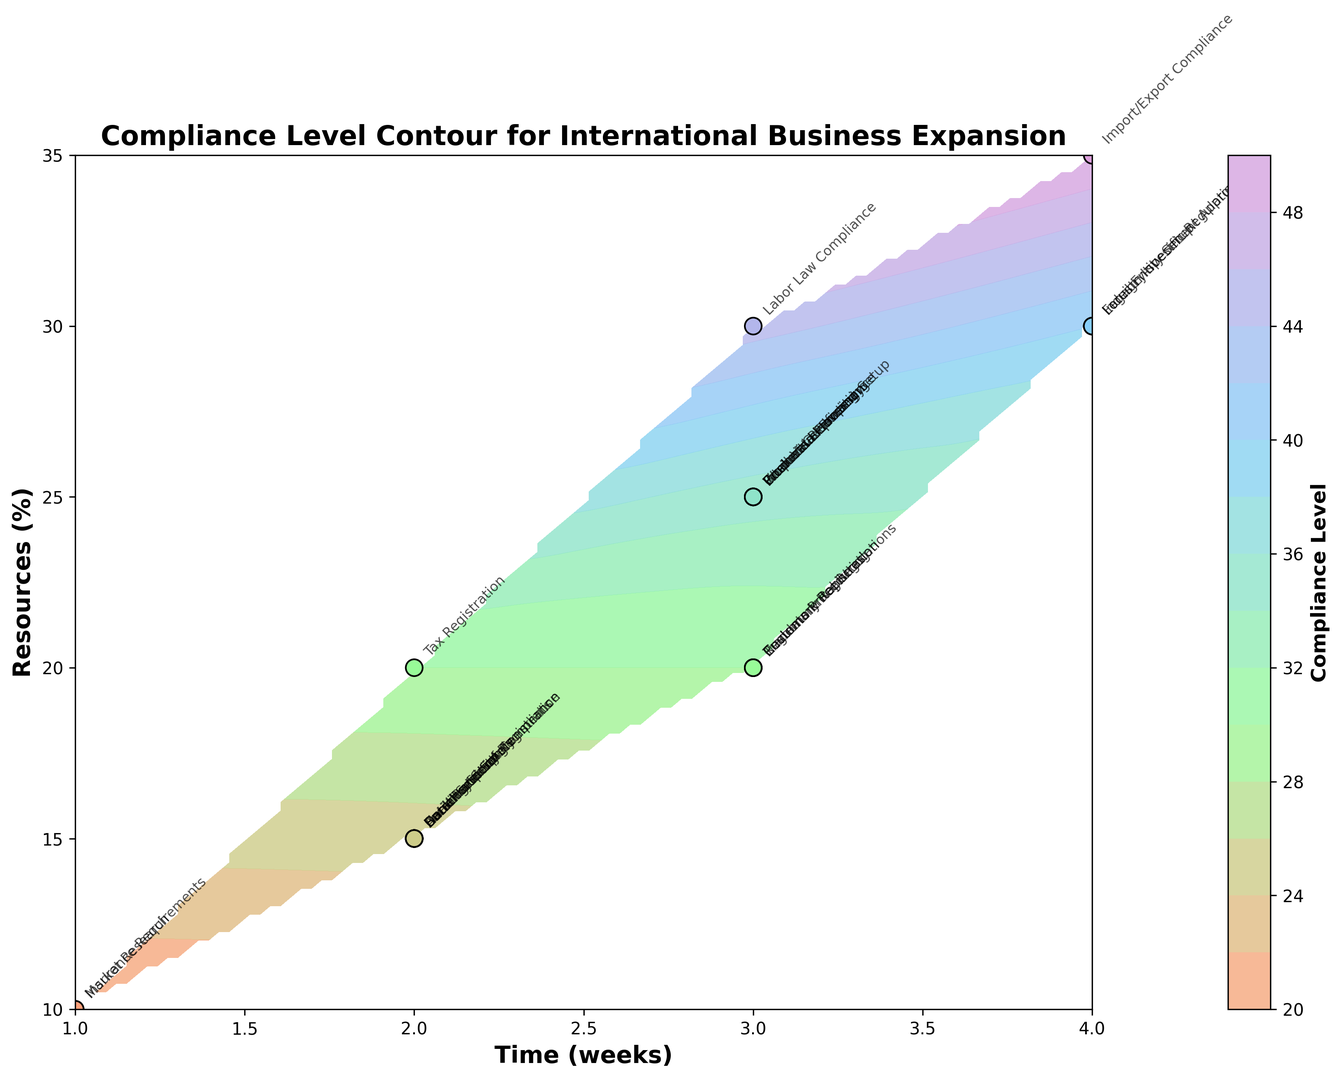What compliance task requires the maximum resources? From the scatter plot on the contour map, the task that is positioned at the highest y-value indicates the maximum resources required. Import/Export Compliance is at 35%, which is the highest among other compliance tasks.
Answer: Import/Export Compliance Which task takes the longest time to complete? On the x-axis, the task furthest to the right represents the longest time. Both Legal Entity Setup, Import/Export Compliance, Foreign Investment Approval, and Industry-specific Regulations are plotted furthest to the right at 4 weeks.
Answer: Legal Entity Setup, Import/Export Compliance, Foreign Investment Approval, Industry-specific Regulations Is there any task that both takes 3 weeks to complete and requires exactly 25% of resources? Look for tasks that have the coordinates (3, 25) on the contour map. Several tasks, including Business Licensing, Financial Reporting Setup, Intellectual Property, Product Certification, Work Visa Processing, and Corporate Governance fall at this point.
Answer: Business Licensing, Financial Reporting Setup, Intellectual Property, Product Certification, Work Visa Processing, Corporate Governance Which tasks need less than 2 weeks and less than 20% of resources? Points left of x = 2 and below y = 20 on the contour plot indicate tasks requiring less than 2 weeks and 20% of resources. Market Research and Insurance Requirements meet these criteria.
Answer: Market Research, Insurance Requirements For tasks taking 2 weeks, how do their resource requirements compare? Examine points plotted at x = 2. Tax Registration requires 20%, Data Protection requires 15%, Banking Setup requires 15%, Health and Safety requires 15%, Currency Controls require 15%, Local Partner Agreements require 15%, Anti-corruption Compliance requires 15%, Social Security Registration requires 15%. Tax Registration has the highest resource requirement among these.
Answer: Tax Registration Find the average compliance level of tasks that require exactly 30% resources. Identify tasks at y = 30 and obtain their compliance levels, then average them. Tasks: Legal Entity Setup (40), Labor Law Compliance (45), Foreign Investment Approval (40), Industry-specific Regulations (40), Trademark Registration (30). (40 + 45 + 40 + 40 + 30) / 5 = 39.
Answer: 39 Which task has the highest compliance level and how significant is it? On the color bar, the darkest or most intense color indicates the highest compliance level. Find the corresponding task. Import/Export Compliance at the compliance level of 50 is the highest.
Answer: Import/Export Compliance Compare the compliance levels of Data Protection and Environmental Regulations. Which has a higher level? Locate both tasks on the plot and compare their color density. Data Protection has a compliance level of 25, and Environmental Regulations have a compliance level of 30. Environmental Regulations has a higher compliance level.
Answer: Environmental Regulations 